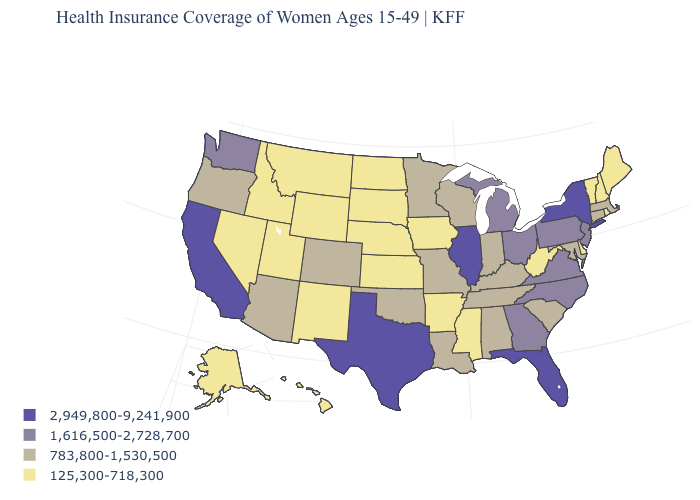Name the states that have a value in the range 125,300-718,300?
Quick response, please. Alaska, Arkansas, Delaware, Hawaii, Idaho, Iowa, Kansas, Maine, Mississippi, Montana, Nebraska, Nevada, New Hampshire, New Mexico, North Dakota, Rhode Island, South Dakota, Utah, Vermont, West Virginia, Wyoming. How many symbols are there in the legend?
Concise answer only. 4. What is the value of Kansas?
Short answer required. 125,300-718,300. Name the states that have a value in the range 125,300-718,300?
Concise answer only. Alaska, Arkansas, Delaware, Hawaii, Idaho, Iowa, Kansas, Maine, Mississippi, Montana, Nebraska, Nevada, New Hampshire, New Mexico, North Dakota, Rhode Island, South Dakota, Utah, Vermont, West Virginia, Wyoming. Name the states that have a value in the range 1,616,500-2,728,700?
Short answer required. Georgia, Michigan, New Jersey, North Carolina, Ohio, Pennsylvania, Virginia, Washington. What is the highest value in the USA?
Concise answer only. 2,949,800-9,241,900. What is the value of Florida?
Quick response, please. 2,949,800-9,241,900. Does Maryland have a lower value than Kentucky?
Give a very brief answer. No. Does Delaware have the highest value in the USA?
Concise answer only. No. Is the legend a continuous bar?
Be succinct. No. What is the lowest value in states that border Missouri?
Keep it brief. 125,300-718,300. Among the states that border New Mexico , which have the lowest value?
Short answer required. Utah. Name the states that have a value in the range 783,800-1,530,500?
Give a very brief answer. Alabama, Arizona, Colorado, Connecticut, Indiana, Kentucky, Louisiana, Maryland, Massachusetts, Minnesota, Missouri, Oklahoma, Oregon, South Carolina, Tennessee, Wisconsin. What is the value of Connecticut?
Concise answer only. 783,800-1,530,500. 